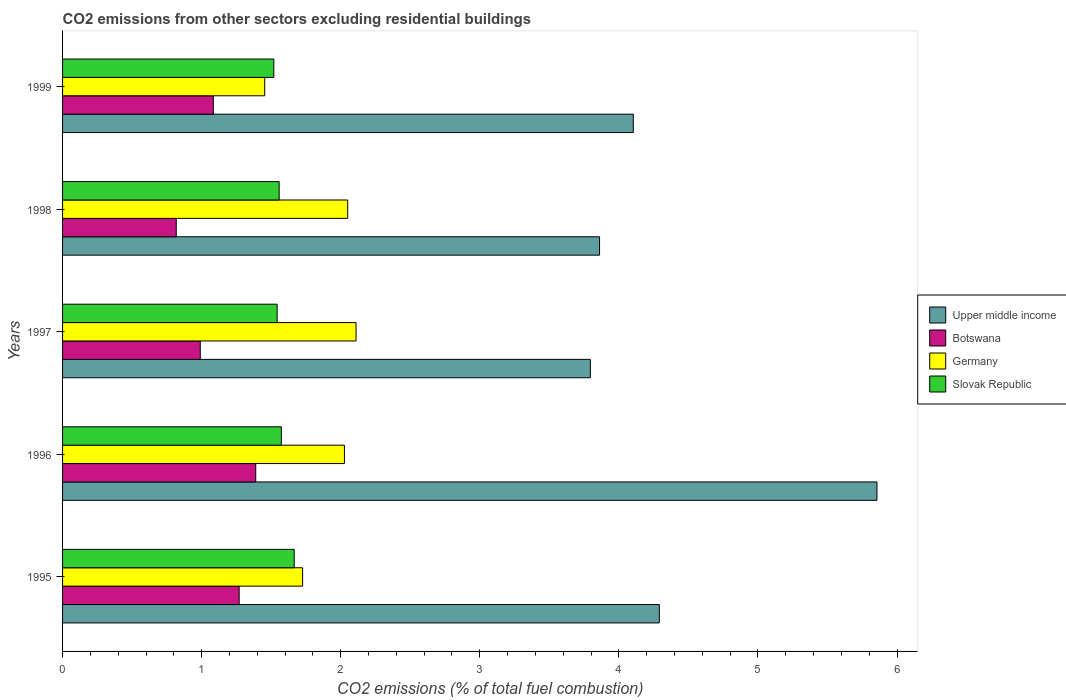How many different coloured bars are there?
Make the answer very short. 4. Are the number of bars per tick equal to the number of legend labels?
Your answer should be compact. Yes. What is the label of the 3rd group of bars from the top?
Offer a very short reply. 1997. What is the total CO2 emitted in Botswana in 1999?
Provide a short and direct response. 1.08. Across all years, what is the maximum total CO2 emitted in Upper middle income?
Ensure brevity in your answer.  5.86. Across all years, what is the minimum total CO2 emitted in Germany?
Keep it short and to the point. 1.45. In which year was the total CO2 emitted in Slovak Republic minimum?
Provide a succinct answer. 1999. What is the total total CO2 emitted in Botswana in the graph?
Provide a short and direct response. 5.55. What is the difference between the total CO2 emitted in Germany in 1998 and that in 1999?
Your answer should be very brief. 0.6. What is the difference between the total CO2 emitted in Upper middle income in 1996 and the total CO2 emitted in Slovak Republic in 1997?
Provide a succinct answer. 4.31. What is the average total CO2 emitted in Germany per year?
Make the answer very short. 1.87. In the year 1996, what is the difference between the total CO2 emitted in Germany and total CO2 emitted in Slovak Republic?
Your response must be concise. 0.45. What is the ratio of the total CO2 emitted in Upper middle income in 1997 to that in 1998?
Your answer should be compact. 0.98. Is the total CO2 emitted in Botswana in 1995 less than that in 1998?
Your answer should be compact. No. What is the difference between the highest and the second highest total CO2 emitted in Botswana?
Provide a short and direct response. 0.12. What is the difference between the highest and the lowest total CO2 emitted in Germany?
Ensure brevity in your answer.  0.66. Is the sum of the total CO2 emitted in Germany in 1997 and 1999 greater than the maximum total CO2 emitted in Botswana across all years?
Offer a very short reply. Yes. What does the 1st bar from the top in 1997 represents?
Ensure brevity in your answer.  Slovak Republic. Are all the bars in the graph horizontal?
Offer a very short reply. Yes. How many years are there in the graph?
Offer a very short reply. 5. What is the difference between two consecutive major ticks on the X-axis?
Offer a very short reply. 1. Does the graph contain any zero values?
Offer a terse response. No. Does the graph contain grids?
Provide a short and direct response. No. Where does the legend appear in the graph?
Ensure brevity in your answer.  Center right. What is the title of the graph?
Offer a terse response. CO2 emissions from other sectors excluding residential buildings. What is the label or title of the X-axis?
Your answer should be compact. CO2 emissions (% of total fuel combustion). What is the label or title of the Y-axis?
Provide a short and direct response. Years. What is the CO2 emissions (% of total fuel combustion) of Upper middle income in 1995?
Offer a very short reply. 4.29. What is the CO2 emissions (% of total fuel combustion) in Botswana in 1995?
Your answer should be very brief. 1.27. What is the CO2 emissions (% of total fuel combustion) in Germany in 1995?
Offer a very short reply. 1.73. What is the CO2 emissions (% of total fuel combustion) in Slovak Republic in 1995?
Offer a terse response. 1.67. What is the CO2 emissions (% of total fuel combustion) in Upper middle income in 1996?
Your answer should be very brief. 5.86. What is the CO2 emissions (% of total fuel combustion) in Botswana in 1996?
Ensure brevity in your answer.  1.39. What is the CO2 emissions (% of total fuel combustion) of Germany in 1996?
Provide a succinct answer. 2.03. What is the CO2 emissions (% of total fuel combustion) in Slovak Republic in 1996?
Your answer should be very brief. 1.57. What is the CO2 emissions (% of total fuel combustion) of Upper middle income in 1997?
Keep it short and to the point. 3.79. What is the CO2 emissions (% of total fuel combustion) in Botswana in 1997?
Give a very brief answer. 0.99. What is the CO2 emissions (% of total fuel combustion) of Germany in 1997?
Offer a very short reply. 2.11. What is the CO2 emissions (% of total fuel combustion) in Slovak Republic in 1997?
Provide a short and direct response. 1.54. What is the CO2 emissions (% of total fuel combustion) in Upper middle income in 1998?
Give a very brief answer. 3.86. What is the CO2 emissions (% of total fuel combustion) in Botswana in 1998?
Give a very brief answer. 0.82. What is the CO2 emissions (% of total fuel combustion) of Germany in 1998?
Provide a short and direct response. 2.05. What is the CO2 emissions (% of total fuel combustion) in Slovak Republic in 1998?
Provide a succinct answer. 1.56. What is the CO2 emissions (% of total fuel combustion) of Upper middle income in 1999?
Make the answer very short. 4.1. What is the CO2 emissions (% of total fuel combustion) in Botswana in 1999?
Offer a terse response. 1.08. What is the CO2 emissions (% of total fuel combustion) in Germany in 1999?
Give a very brief answer. 1.45. What is the CO2 emissions (% of total fuel combustion) of Slovak Republic in 1999?
Your response must be concise. 1.52. Across all years, what is the maximum CO2 emissions (% of total fuel combustion) of Upper middle income?
Provide a short and direct response. 5.86. Across all years, what is the maximum CO2 emissions (% of total fuel combustion) of Botswana?
Provide a short and direct response. 1.39. Across all years, what is the maximum CO2 emissions (% of total fuel combustion) of Germany?
Provide a short and direct response. 2.11. Across all years, what is the maximum CO2 emissions (% of total fuel combustion) of Slovak Republic?
Provide a succinct answer. 1.67. Across all years, what is the minimum CO2 emissions (% of total fuel combustion) in Upper middle income?
Your answer should be very brief. 3.79. Across all years, what is the minimum CO2 emissions (% of total fuel combustion) of Botswana?
Give a very brief answer. 0.82. Across all years, what is the minimum CO2 emissions (% of total fuel combustion) in Germany?
Make the answer very short. 1.45. Across all years, what is the minimum CO2 emissions (% of total fuel combustion) of Slovak Republic?
Provide a short and direct response. 1.52. What is the total CO2 emissions (% of total fuel combustion) in Upper middle income in the graph?
Your answer should be very brief. 21.91. What is the total CO2 emissions (% of total fuel combustion) in Botswana in the graph?
Make the answer very short. 5.55. What is the total CO2 emissions (% of total fuel combustion) of Germany in the graph?
Ensure brevity in your answer.  9.37. What is the total CO2 emissions (% of total fuel combustion) of Slovak Republic in the graph?
Provide a short and direct response. 7.86. What is the difference between the CO2 emissions (% of total fuel combustion) of Upper middle income in 1995 and that in 1996?
Make the answer very short. -1.56. What is the difference between the CO2 emissions (% of total fuel combustion) of Botswana in 1995 and that in 1996?
Keep it short and to the point. -0.12. What is the difference between the CO2 emissions (% of total fuel combustion) in Germany in 1995 and that in 1996?
Offer a very short reply. -0.3. What is the difference between the CO2 emissions (% of total fuel combustion) in Slovak Republic in 1995 and that in 1996?
Your answer should be very brief. 0.09. What is the difference between the CO2 emissions (% of total fuel combustion) of Upper middle income in 1995 and that in 1997?
Your answer should be very brief. 0.5. What is the difference between the CO2 emissions (% of total fuel combustion) of Botswana in 1995 and that in 1997?
Make the answer very short. 0.28. What is the difference between the CO2 emissions (% of total fuel combustion) in Germany in 1995 and that in 1997?
Provide a short and direct response. -0.38. What is the difference between the CO2 emissions (% of total fuel combustion) of Slovak Republic in 1995 and that in 1997?
Offer a very short reply. 0.12. What is the difference between the CO2 emissions (% of total fuel combustion) in Upper middle income in 1995 and that in 1998?
Offer a very short reply. 0.43. What is the difference between the CO2 emissions (% of total fuel combustion) in Botswana in 1995 and that in 1998?
Your answer should be compact. 0.45. What is the difference between the CO2 emissions (% of total fuel combustion) of Germany in 1995 and that in 1998?
Your answer should be compact. -0.32. What is the difference between the CO2 emissions (% of total fuel combustion) of Slovak Republic in 1995 and that in 1998?
Your response must be concise. 0.11. What is the difference between the CO2 emissions (% of total fuel combustion) of Upper middle income in 1995 and that in 1999?
Give a very brief answer. 0.19. What is the difference between the CO2 emissions (% of total fuel combustion) in Botswana in 1995 and that in 1999?
Offer a terse response. 0.19. What is the difference between the CO2 emissions (% of total fuel combustion) in Germany in 1995 and that in 1999?
Offer a terse response. 0.27. What is the difference between the CO2 emissions (% of total fuel combustion) in Slovak Republic in 1995 and that in 1999?
Your answer should be very brief. 0.15. What is the difference between the CO2 emissions (% of total fuel combustion) of Upper middle income in 1996 and that in 1997?
Provide a succinct answer. 2.06. What is the difference between the CO2 emissions (% of total fuel combustion) in Botswana in 1996 and that in 1997?
Keep it short and to the point. 0.4. What is the difference between the CO2 emissions (% of total fuel combustion) in Germany in 1996 and that in 1997?
Offer a terse response. -0.08. What is the difference between the CO2 emissions (% of total fuel combustion) of Slovak Republic in 1996 and that in 1997?
Give a very brief answer. 0.03. What is the difference between the CO2 emissions (% of total fuel combustion) in Upper middle income in 1996 and that in 1998?
Provide a short and direct response. 1.99. What is the difference between the CO2 emissions (% of total fuel combustion) of Botswana in 1996 and that in 1998?
Keep it short and to the point. 0.57. What is the difference between the CO2 emissions (% of total fuel combustion) in Germany in 1996 and that in 1998?
Your answer should be very brief. -0.02. What is the difference between the CO2 emissions (% of total fuel combustion) of Slovak Republic in 1996 and that in 1998?
Your response must be concise. 0.02. What is the difference between the CO2 emissions (% of total fuel combustion) of Upper middle income in 1996 and that in 1999?
Offer a very short reply. 1.75. What is the difference between the CO2 emissions (% of total fuel combustion) in Botswana in 1996 and that in 1999?
Your answer should be very brief. 0.3. What is the difference between the CO2 emissions (% of total fuel combustion) in Germany in 1996 and that in 1999?
Offer a terse response. 0.57. What is the difference between the CO2 emissions (% of total fuel combustion) of Slovak Republic in 1996 and that in 1999?
Offer a very short reply. 0.05. What is the difference between the CO2 emissions (% of total fuel combustion) of Upper middle income in 1997 and that in 1998?
Offer a terse response. -0.07. What is the difference between the CO2 emissions (% of total fuel combustion) of Botswana in 1997 and that in 1998?
Your response must be concise. 0.17. What is the difference between the CO2 emissions (% of total fuel combustion) of Slovak Republic in 1997 and that in 1998?
Give a very brief answer. -0.01. What is the difference between the CO2 emissions (% of total fuel combustion) of Upper middle income in 1997 and that in 1999?
Offer a very short reply. -0.31. What is the difference between the CO2 emissions (% of total fuel combustion) in Botswana in 1997 and that in 1999?
Ensure brevity in your answer.  -0.09. What is the difference between the CO2 emissions (% of total fuel combustion) of Germany in 1997 and that in 1999?
Ensure brevity in your answer.  0.66. What is the difference between the CO2 emissions (% of total fuel combustion) in Slovak Republic in 1997 and that in 1999?
Offer a terse response. 0.02. What is the difference between the CO2 emissions (% of total fuel combustion) in Upper middle income in 1998 and that in 1999?
Ensure brevity in your answer.  -0.24. What is the difference between the CO2 emissions (% of total fuel combustion) of Botswana in 1998 and that in 1999?
Offer a very short reply. -0.27. What is the difference between the CO2 emissions (% of total fuel combustion) of Germany in 1998 and that in 1999?
Offer a terse response. 0.6. What is the difference between the CO2 emissions (% of total fuel combustion) of Slovak Republic in 1998 and that in 1999?
Give a very brief answer. 0.04. What is the difference between the CO2 emissions (% of total fuel combustion) of Upper middle income in 1995 and the CO2 emissions (% of total fuel combustion) of Botswana in 1996?
Your answer should be very brief. 2.9. What is the difference between the CO2 emissions (% of total fuel combustion) of Upper middle income in 1995 and the CO2 emissions (% of total fuel combustion) of Germany in 1996?
Offer a very short reply. 2.26. What is the difference between the CO2 emissions (% of total fuel combustion) of Upper middle income in 1995 and the CO2 emissions (% of total fuel combustion) of Slovak Republic in 1996?
Provide a succinct answer. 2.72. What is the difference between the CO2 emissions (% of total fuel combustion) in Botswana in 1995 and the CO2 emissions (% of total fuel combustion) in Germany in 1996?
Offer a very short reply. -0.76. What is the difference between the CO2 emissions (% of total fuel combustion) of Botswana in 1995 and the CO2 emissions (% of total fuel combustion) of Slovak Republic in 1996?
Offer a very short reply. -0.3. What is the difference between the CO2 emissions (% of total fuel combustion) of Germany in 1995 and the CO2 emissions (% of total fuel combustion) of Slovak Republic in 1996?
Your response must be concise. 0.15. What is the difference between the CO2 emissions (% of total fuel combustion) of Upper middle income in 1995 and the CO2 emissions (% of total fuel combustion) of Botswana in 1997?
Your response must be concise. 3.3. What is the difference between the CO2 emissions (% of total fuel combustion) in Upper middle income in 1995 and the CO2 emissions (% of total fuel combustion) in Germany in 1997?
Offer a very short reply. 2.18. What is the difference between the CO2 emissions (% of total fuel combustion) in Upper middle income in 1995 and the CO2 emissions (% of total fuel combustion) in Slovak Republic in 1997?
Your response must be concise. 2.75. What is the difference between the CO2 emissions (% of total fuel combustion) in Botswana in 1995 and the CO2 emissions (% of total fuel combustion) in Germany in 1997?
Your response must be concise. -0.84. What is the difference between the CO2 emissions (% of total fuel combustion) of Botswana in 1995 and the CO2 emissions (% of total fuel combustion) of Slovak Republic in 1997?
Provide a succinct answer. -0.27. What is the difference between the CO2 emissions (% of total fuel combustion) of Germany in 1995 and the CO2 emissions (% of total fuel combustion) of Slovak Republic in 1997?
Provide a succinct answer. 0.18. What is the difference between the CO2 emissions (% of total fuel combustion) in Upper middle income in 1995 and the CO2 emissions (% of total fuel combustion) in Botswana in 1998?
Provide a succinct answer. 3.47. What is the difference between the CO2 emissions (% of total fuel combustion) of Upper middle income in 1995 and the CO2 emissions (% of total fuel combustion) of Germany in 1998?
Your response must be concise. 2.24. What is the difference between the CO2 emissions (% of total fuel combustion) of Upper middle income in 1995 and the CO2 emissions (% of total fuel combustion) of Slovak Republic in 1998?
Provide a short and direct response. 2.73. What is the difference between the CO2 emissions (% of total fuel combustion) of Botswana in 1995 and the CO2 emissions (% of total fuel combustion) of Germany in 1998?
Your response must be concise. -0.78. What is the difference between the CO2 emissions (% of total fuel combustion) in Botswana in 1995 and the CO2 emissions (% of total fuel combustion) in Slovak Republic in 1998?
Offer a very short reply. -0.29. What is the difference between the CO2 emissions (% of total fuel combustion) of Germany in 1995 and the CO2 emissions (% of total fuel combustion) of Slovak Republic in 1998?
Your response must be concise. 0.17. What is the difference between the CO2 emissions (% of total fuel combustion) of Upper middle income in 1995 and the CO2 emissions (% of total fuel combustion) of Botswana in 1999?
Provide a short and direct response. 3.21. What is the difference between the CO2 emissions (% of total fuel combustion) in Upper middle income in 1995 and the CO2 emissions (% of total fuel combustion) in Germany in 1999?
Your answer should be compact. 2.84. What is the difference between the CO2 emissions (% of total fuel combustion) in Upper middle income in 1995 and the CO2 emissions (% of total fuel combustion) in Slovak Republic in 1999?
Offer a terse response. 2.77. What is the difference between the CO2 emissions (% of total fuel combustion) of Botswana in 1995 and the CO2 emissions (% of total fuel combustion) of Germany in 1999?
Offer a very short reply. -0.18. What is the difference between the CO2 emissions (% of total fuel combustion) of Botswana in 1995 and the CO2 emissions (% of total fuel combustion) of Slovak Republic in 1999?
Keep it short and to the point. -0.25. What is the difference between the CO2 emissions (% of total fuel combustion) of Germany in 1995 and the CO2 emissions (% of total fuel combustion) of Slovak Republic in 1999?
Your response must be concise. 0.21. What is the difference between the CO2 emissions (% of total fuel combustion) of Upper middle income in 1996 and the CO2 emissions (% of total fuel combustion) of Botswana in 1997?
Provide a short and direct response. 4.87. What is the difference between the CO2 emissions (% of total fuel combustion) in Upper middle income in 1996 and the CO2 emissions (% of total fuel combustion) in Germany in 1997?
Offer a very short reply. 3.75. What is the difference between the CO2 emissions (% of total fuel combustion) of Upper middle income in 1996 and the CO2 emissions (% of total fuel combustion) of Slovak Republic in 1997?
Give a very brief answer. 4.31. What is the difference between the CO2 emissions (% of total fuel combustion) in Botswana in 1996 and the CO2 emissions (% of total fuel combustion) in Germany in 1997?
Make the answer very short. -0.72. What is the difference between the CO2 emissions (% of total fuel combustion) of Botswana in 1996 and the CO2 emissions (% of total fuel combustion) of Slovak Republic in 1997?
Provide a short and direct response. -0.15. What is the difference between the CO2 emissions (% of total fuel combustion) in Germany in 1996 and the CO2 emissions (% of total fuel combustion) in Slovak Republic in 1997?
Keep it short and to the point. 0.48. What is the difference between the CO2 emissions (% of total fuel combustion) of Upper middle income in 1996 and the CO2 emissions (% of total fuel combustion) of Botswana in 1998?
Offer a terse response. 5.04. What is the difference between the CO2 emissions (% of total fuel combustion) in Upper middle income in 1996 and the CO2 emissions (% of total fuel combustion) in Germany in 1998?
Make the answer very short. 3.81. What is the difference between the CO2 emissions (% of total fuel combustion) of Upper middle income in 1996 and the CO2 emissions (% of total fuel combustion) of Slovak Republic in 1998?
Your answer should be compact. 4.3. What is the difference between the CO2 emissions (% of total fuel combustion) in Botswana in 1996 and the CO2 emissions (% of total fuel combustion) in Germany in 1998?
Your answer should be compact. -0.66. What is the difference between the CO2 emissions (% of total fuel combustion) of Botswana in 1996 and the CO2 emissions (% of total fuel combustion) of Slovak Republic in 1998?
Keep it short and to the point. -0.17. What is the difference between the CO2 emissions (% of total fuel combustion) of Germany in 1996 and the CO2 emissions (% of total fuel combustion) of Slovak Republic in 1998?
Provide a succinct answer. 0.47. What is the difference between the CO2 emissions (% of total fuel combustion) of Upper middle income in 1996 and the CO2 emissions (% of total fuel combustion) of Botswana in 1999?
Provide a short and direct response. 4.77. What is the difference between the CO2 emissions (% of total fuel combustion) in Upper middle income in 1996 and the CO2 emissions (% of total fuel combustion) in Germany in 1999?
Offer a terse response. 4.4. What is the difference between the CO2 emissions (% of total fuel combustion) in Upper middle income in 1996 and the CO2 emissions (% of total fuel combustion) in Slovak Republic in 1999?
Keep it short and to the point. 4.34. What is the difference between the CO2 emissions (% of total fuel combustion) of Botswana in 1996 and the CO2 emissions (% of total fuel combustion) of Germany in 1999?
Offer a terse response. -0.06. What is the difference between the CO2 emissions (% of total fuel combustion) of Botswana in 1996 and the CO2 emissions (% of total fuel combustion) of Slovak Republic in 1999?
Your response must be concise. -0.13. What is the difference between the CO2 emissions (% of total fuel combustion) in Germany in 1996 and the CO2 emissions (% of total fuel combustion) in Slovak Republic in 1999?
Your answer should be very brief. 0.51. What is the difference between the CO2 emissions (% of total fuel combustion) of Upper middle income in 1997 and the CO2 emissions (% of total fuel combustion) of Botswana in 1998?
Give a very brief answer. 2.98. What is the difference between the CO2 emissions (% of total fuel combustion) of Upper middle income in 1997 and the CO2 emissions (% of total fuel combustion) of Germany in 1998?
Provide a succinct answer. 1.74. What is the difference between the CO2 emissions (% of total fuel combustion) in Upper middle income in 1997 and the CO2 emissions (% of total fuel combustion) in Slovak Republic in 1998?
Your answer should be very brief. 2.24. What is the difference between the CO2 emissions (% of total fuel combustion) in Botswana in 1997 and the CO2 emissions (% of total fuel combustion) in Germany in 1998?
Your answer should be very brief. -1.06. What is the difference between the CO2 emissions (% of total fuel combustion) in Botswana in 1997 and the CO2 emissions (% of total fuel combustion) in Slovak Republic in 1998?
Provide a short and direct response. -0.57. What is the difference between the CO2 emissions (% of total fuel combustion) in Germany in 1997 and the CO2 emissions (% of total fuel combustion) in Slovak Republic in 1998?
Your answer should be compact. 0.55. What is the difference between the CO2 emissions (% of total fuel combustion) in Upper middle income in 1997 and the CO2 emissions (% of total fuel combustion) in Botswana in 1999?
Provide a succinct answer. 2.71. What is the difference between the CO2 emissions (% of total fuel combustion) of Upper middle income in 1997 and the CO2 emissions (% of total fuel combustion) of Germany in 1999?
Your answer should be compact. 2.34. What is the difference between the CO2 emissions (% of total fuel combustion) of Upper middle income in 1997 and the CO2 emissions (% of total fuel combustion) of Slovak Republic in 1999?
Give a very brief answer. 2.28. What is the difference between the CO2 emissions (% of total fuel combustion) in Botswana in 1997 and the CO2 emissions (% of total fuel combustion) in Germany in 1999?
Give a very brief answer. -0.46. What is the difference between the CO2 emissions (% of total fuel combustion) of Botswana in 1997 and the CO2 emissions (% of total fuel combustion) of Slovak Republic in 1999?
Offer a very short reply. -0.53. What is the difference between the CO2 emissions (% of total fuel combustion) in Germany in 1997 and the CO2 emissions (% of total fuel combustion) in Slovak Republic in 1999?
Keep it short and to the point. 0.59. What is the difference between the CO2 emissions (% of total fuel combustion) in Upper middle income in 1998 and the CO2 emissions (% of total fuel combustion) in Botswana in 1999?
Give a very brief answer. 2.78. What is the difference between the CO2 emissions (% of total fuel combustion) in Upper middle income in 1998 and the CO2 emissions (% of total fuel combustion) in Germany in 1999?
Provide a short and direct response. 2.41. What is the difference between the CO2 emissions (% of total fuel combustion) in Upper middle income in 1998 and the CO2 emissions (% of total fuel combustion) in Slovak Republic in 1999?
Make the answer very short. 2.34. What is the difference between the CO2 emissions (% of total fuel combustion) in Botswana in 1998 and the CO2 emissions (% of total fuel combustion) in Germany in 1999?
Provide a short and direct response. -0.64. What is the difference between the CO2 emissions (% of total fuel combustion) of Botswana in 1998 and the CO2 emissions (% of total fuel combustion) of Slovak Republic in 1999?
Your answer should be compact. -0.7. What is the difference between the CO2 emissions (% of total fuel combustion) in Germany in 1998 and the CO2 emissions (% of total fuel combustion) in Slovak Republic in 1999?
Offer a terse response. 0.53. What is the average CO2 emissions (% of total fuel combustion) in Upper middle income per year?
Your answer should be compact. 4.38. What is the average CO2 emissions (% of total fuel combustion) in Botswana per year?
Your answer should be very brief. 1.11. What is the average CO2 emissions (% of total fuel combustion) in Germany per year?
Your answer should be very brief. 1.87. What is the average CO2 emissions (% of total fuel combustion) in Slovak Republic per year?
Make the answer very short. 1.57. In the year 1995, what is the difference between the CO2 emissions (% of total fuel combustion) in Upper middle income and CO2 emissions (% of total fuel combustion) in Botswana?
Give a very brief answer. 3.02. In the year 1995, what is the difference between the CO2 emissions (% of total fuel combustion) of Upper middle income and CO2 emissions (% of total fuel combustion) of Germany?
Provide a succinct answer. 2.56. In the year 1995, what is the difference between the CO2 emissions (% of total fuel combustion) in Upper middle income and CO2 emissions (% of total fuel combustion) in Slovak Republic?
Your answer should be very brief. 2.63. In the year 1995, what is the difference between the CO2 emissions (% of total fuel combustion) in Botswana and CO2 emissions (% of total fuel combustion) in Germany?
Your response must be concise. -0.46. In the year 1995, what is the difference between the CO2 emissions (% of total fuel combustion) in Botswana and CO2 emissions (% of total fuel combustion) in Slovak Republic?
Provide a short and direct response. -0.4. In the year 1995, what is the difference between the CO2 emissions (% of total fuel combustion) of Germany and CO2 emissions (% of total fuel combustion) of Slovak Republic?
Offer a terse response. 0.06. In the year 1996, what is the difference between the CO2 emissions (% of total fuel combustion) of Upper middle income and CO2 emissions (% of total fuel combustion) of Botswana?
Give a very brief answer. 4.47. In the year 1996, what is the difference between the CO2 emissions (% of total fuel combustion) in Upper middle income and CO2 emissions (% of total fuel combustion) in Germany?
Ensure brevity in your answer.  3.83. In the year 1996, what is the difference between the CO2 emissions (% of total fuel combustion) in Upper middle income and CO2 emissions (% of total fuel combustion) in Slovak Republic?
Provide a succinct answer. 4.28. In the year 1996, what is the difference between the CO2 emissions (% of total fuel combustion) of Botswana and CO2 emissions (% of total fuel combustion) of Germany?
Offer a terse response. -0.64. In the year 1996, what is the difference between the CO2 emissions (% of total fuel combustion) in Botswana and CO2 emissions (% of total fuel combustion) in Slovak Republic?
Ensure brevity in your answer.  -0.18. In the year 1996, what is the difference between the CO2 emissions (% of total fuel combustion) of Germany and CO2 emissions (% of total fuel combustion) of Slovak Republic?
Your response must be concise. 0.45. In the year 1997, what is the difference between the CO2 emissions (% of total fuel combustion) of Upper middle income and CO2 emissions (% of total fuel combustion) of Botswana?
Ensure brevity in your answer.  2.8. In the year 1997, what is the difference between the CO2 emissions (% of total fuel combustion) of Upper middle income and CO2 emissions (% of total fuel combustion) of Germany?
Ensure brevity in your answer.  1.68. In the year 1997, what is the difference between the CO2 emissions (% of total fuel combustion) in Upper middle income and CO2 emissions (% of total fuel combustion) in Slovak Republic?
Ensure brevity in your answer.  2.25. In the year 1997, what is the difference between the CO2 emissions (% of total fuel combustion) of Botswana and CO2 emissions (% of total fuel combustion) of Germany?
Keep it short and to the point. -1.12. In the year 1997, what is the difference between the CO2 emissions (% of total fuel combustion) of Botswana and CO2 emissions (% of total fuel combustion) of Slovak Republic?
Ensure brevity in your answer.  -0.55. In the year 1997, what is the difference between the CO2 emissions (% of total fuel combustion) in Germany and CO2 emissions (% of total fuel combustion) in Slovak Republic?
Give a very brief answer. 0.57. In the year 1998, what is the difference between the CO2 emissions (% of total fuel combustion) in Upper middle income and CO2 emissions (% of total fuel combustion) in Botswana?
Offer a very short reply. 3.04. In the year 1998, what is the difference between the CO2 emissions (% of total fuel combustion) in Upper middle income and CO2 emissions (% of total fuel combustion) in Germany?
Keep it short and to the point. 1.81. In the year 1998, what is the difference between the CO2 emissions (% of total fuel combustion) of Upper middle income and CO2 emissions (% of total fuel combustion) of Slovak Republic?
Provide a succinct answer. 2.3. In the year 1998, what is the difference between the CO2 emissions (% of total fuel combustion) in Botswana and CO2 emissions (% of total fuel combustion) in Germany?
Provide a succinct answer. -1.23. In the year 1998, what is the difference between the CO2 emissions (% of total fuel combustion) of Botswana and CO2 emissions (% of total fuel combustion) of Slovak Republic?
Your response must be concise. -0.74. In the year 1998, what is the difference between the CO2 emissions (% of total fuel combustion) in Germany and CO2 emissions (% of total fuel combustion) in Slovak Republic?
Ensure brevity in your answer.  0.49. In the year 1999, what is the difference between the CO2 emissions (% of total fuel combustion) of Upper middle income and CO2 emissions (% of total fuel combustion) of Botswana?
Your answer should be very brief. 3.02. In the year 1999, what is the difference between the CO2 emissions (% of total fuel combustion) of Upper middle income and CO2 emissions (% of total fuel combustion) of Germany?
Offer a very short reply. 2.65. In the year 1999, what is the difference between the CO2 emissions (% of total fuel combustion) of Upper middle income and CO2 emissions (% of total fuel combustion) of Slovak Republic?
Give a very brief answer. 2.58. In the year 1999, what is the difference between the CO2 emissions (% of total fuel combustion) of Botswana and CO2 emissions (% of total fuel combustion) of Germany?
Keep it short and to the point. -0.37. In the year 1999, what is the difference between the CO2 emissions (% of total fuel combustion) of Botswana and CO2 emissions (% of total fuel combustion) of Slovak Republic?
Provide a short and direct response. -0.43. In the year 1999, what is the difference between the CO2 emissions (% of total fuel combustion) in Germany and CO2 emissions (% of total fuel combustion) in Slovak Republic?
Keep it short and to the point. -0.07. What is the ratio of the CO2 emissions (% of total fuel combustion) of Upper middle income in 1995 to that in 1996?
Give a very brief answer. 0.73. What is the ratio of the CO2 emissions (% of total fuel combustion) in Botswana in 1995 to that in 1996?
Offer a terse response. 0.91. What is the ratio of the CO2 emissions (% of total fuel combustion) of Germany in 1995 to that in 1996?
Your response must be concise. 0.85. What is the ratio of the CO2 emissions (% of total fuel combustion) of Slovak Republic in 1995 to that in 1996?
Offer a very short reply. 1.06. What is the ratio of the CO2 emissions (% of total fuel combustion) of Upper middle income in 1995 to that in 1997?
Provide a short and direct response. 1.13. What is the ratio of the CO2 emissions (% of total fuel combustion) of Botswana in 1995 to that in 1997?
Your answer should be compact. 1.28. What is the ratio of the CO2 emissions (% of total fuel combustion) of Germany in 1995 to that in 1997?
Ensure brevity in your answer.  0.82. What is the ratio of the CO2 emissions (% of total fuel combustion) in Slovak Republic in 1995 to that in 1997?
Provide a short and direct response. 1.08. What is the ratio of the CO2 emissions (% of total fuel combustion) in Upper middle income in 1995 to that in 1998?
Ensure brevity in your answer.  1.11. What is the ratio of the CO2 emissions (% of total fuel combustion) of Botswana in 1995 to that in 1998?
Keep it short and to the point. 1.55. What is the ratio of the CO2 emissions (% of total fuel combustion) in Germany in 1995 to that in 1998?
Offer a very short reply. 0.84. What is the ratio of the CO2 emissions (% of total fuel combustion) of Slovak Republic in 1995 to that in 1998?
Offer a terse response. 1.07. What is the ratio of the CO2 emissions (% of total fuel combustion) of Upper middle income in 1995 to that in 1999?
Your answer should be very brief. 1.05. What is the ratio of the CO2 emissions (% of total fuel combustion) of Botswana in 1995 to that in 1999?
Offer a terse response. 1.17. What is the ratio of the CO2 emissions (% of total fuel combustion) of Germany in 1995 to that in 1999?
Give a very brief answer. 1.19. What is the ratio of the CO2 emissions (% of total fuel combustion) in Slovak Republic in 1995 to that in 1999?
Provide a succinct answer. 1.1. What is the ratio of the CO2 emissions (% of total fuel combustion) of Upper middle income in 1996 to that in 1997?
Your answer should be very brief. 1.54. What is the ratio of the CO2 emissions (% of total fuel combustion) of Botswana in 1996 to that in 1997?
Give a very brief answer. 1.4. What is the ratio of the CO2 emissions (% of total fuel combustion) in Germany in 1996 to that in 1997?
Offer a very short reply. 0.96. What is the ratio of the CO2 emissions (% of total fuel combustion) in Slovak Republic in 1996 to that in 1997?
Your response must be concise. 1.02. What is the ratio of the CO2 emissions (% of total fuel combustion) of Upper middle income in 1996 to that in 1998?
Provide a short and direct response. 1.52. What is the ratio of the CO2 emissions (% of total fuel combustion) of Botswana in 1996 to that in 1998?
Provide a succinct answer. 1.7. What is the ratio of the CO2 emissions (% of total fuel combustion) in Slovak Republic in 1996 to that in 1998?
Your answer should be very brief. 1.01. What is the ratio of the CO2 emissions (% of total fuel combustion) in Upper middle income in 1996 to that in 1999?
Provide a short and direct response. 1.43. What is the ratio of the CO2 emissions (% of total fuel combustion) of Botswana in 1996 to that in 1999?
Give a very brief answer. 1.28. What is the ratio of the CO2 emissions (% of total fuel combustion) of Germany in 1996 to that in 1999?
Provide a succinct answer. 1.39. What is the ratio of the CO2 emissions (% of total fuel combustion) of Slovak Republic in 1996 to that in 1999?
Provide a short and direct response. 1.04. What is the ratio of the CO2 emissions (% of total fuel combustion) in Upper middle income in 1997 to that in 1998?
Your answer should be compact. 0.98. What is the ratio of the CO2 emissions (% of total fuel combustion) of Botswana in 1997 to that in 1998?
Make the answer very short. 1.21. What is the ratio of the CO2 emissions (% of total fuel combustion) in Germany in 1997 to that in 1998?
Your answer should be very brief. 1.03. What is the ratio of the CO2 emissions (% of total fuel combustion) of Upper middle income in 1997 to that in 1999?
Make the answer very short. 0.92. What is the ratio of the CO2 emissions (% of total fuel combustion) of Botswana in 1997 to that in 1999?
Keep it short and to the point. 0.91. What is the ratio of the CO2 emissions (% of total fuel combustion) in Germany in 1997 to that in 1999?
Offer a terse response. 1.45. What is the ratio of the CO2 emissions (% of total fuel combustion) in Slovak Republic in 1997 to that in 1999?
Keep it short and to the point. 1.02. What is the ratio of the CO2 emissions (% of total fuel combustion) in Upper middle income in 1998 to that in 1999?
Give a very brief answer. 0.94. What is the ratio of the CO2 emissions (% of total fuel combustion) in Botswana in 1998 to that in 1999?
Your answer should be compact. 0.75. What is the ratio of the CO2 emissions (% of total fuel combustion) in Germany in 1998 to that in 1999?
Your answer should be very brief. 1.41. What is the ratio of the CO2 emissions (% of total fuel combustion) in Slovak Republic in 1998 to that in 1999?
Give a very brief answer. 1.03. What is the difference between the highest and the second highest CO2 emissions (% of total fuel combustion) of Upper middle income?
Provide a succinct answer. 1.56. What is the difference between the highest and the second highest CO2 emissions (% of total fuel combustion) in Botswana?
Offer a terse response. 0.12. What is the difference between the highest and the second highest CO2 emissions (% of total fuel combustion) of Germany?
Your answer should be very brief. 0.06. What is the difference between the highest and the second highest CO2 emissions (% of total fuel combustion) of Slovak Republic?
Ensure brevity in your answer.  0.09. What is the difference between the highest and the lowest CO2 emissions (% of total fuel combustion) in Upper middle income?
Your answer should be compact. 2.06. What is the difference between the highest and the lowest CO2 emissions (% of total fuel combustion) in Botswana?
Your answer should be compact. 0.57. What is the difference between the highest and the lowest CO2 emissions (% of total fuel combustion) in Germany?
Your answer should be compact. 0.66. What is the difference between the highest and the lowest CO2 emissions (% of total fuel combustion) in Slovak Republic?
Offer a very short reply. 0.15. 